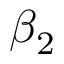Convert formula to latex. <formula><loc_0><loc_0><loc_500><loc_500>\beta _ { 2 }</formula> 